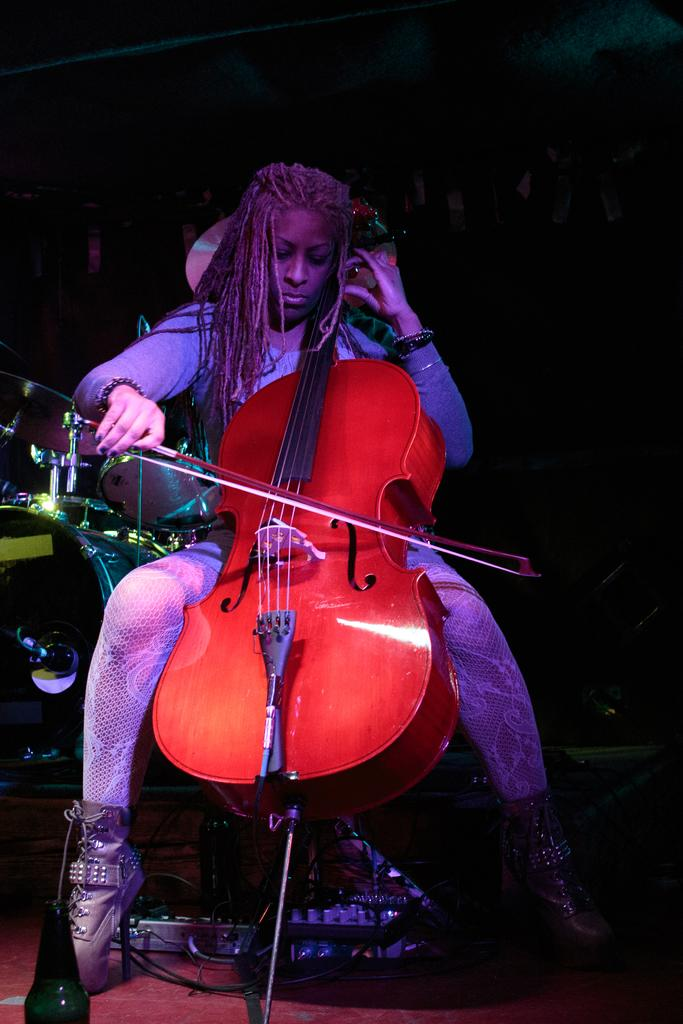Who is present in the image? There is a woman in the image. What is the woman doing in the image? The woman is sitting in the image. What object is the woman holding in her hand? The woman is holding a violin in her hand. What type of coat is the woman wearing in the image? There is no coat visible in the image; the woman is not wearing one. How many friends is the woman with in the image? The image only shows the woman, so there are no friends present. 